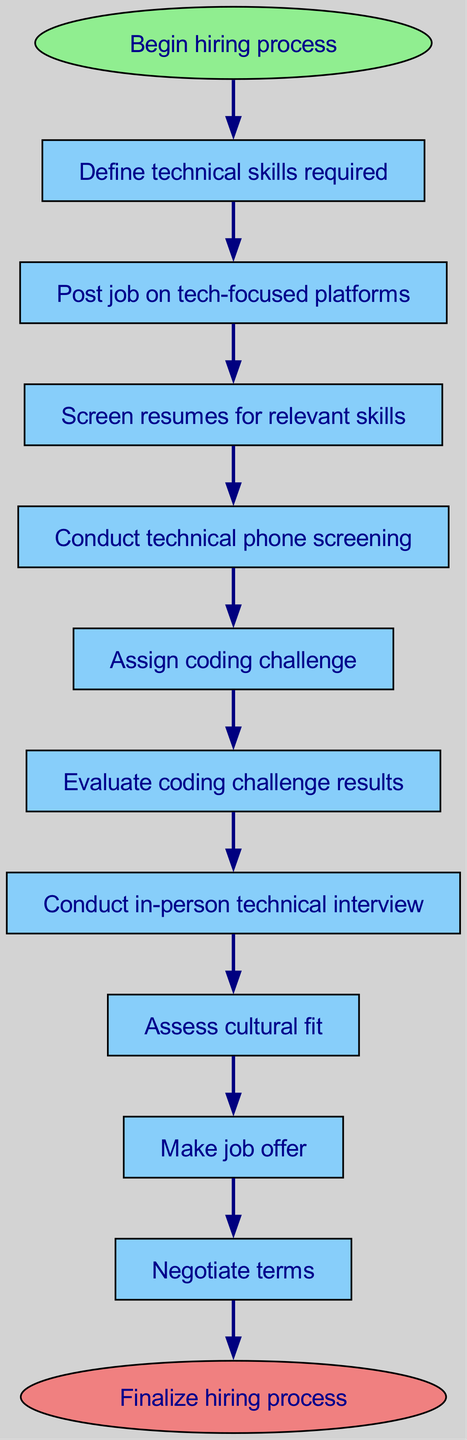What is the first step in the hiring process? The flowchart starts at the "Begin hiring process" node, which leads to the first step labeled "Define technical skills required."
Answer: Define technical skills required How many steps are there in the hiring process? The hiring process has a total of 10 steps (from define skills to negotiate terms). This is verified by counting the steps listed in the diagram.
Answer: 10 What follows after "Conduct in-person technical interview"? The node "Conduct in-person technical interview" is followed by "Assess cultural fit," which means the next step is determining how well the candidate fits the company culture.
Answer: Assess cultural fit Which step involves screening resumes? The step that involves screening resumes is labeled "Screen resumes for relevant skills," which is the third step in the sequence.
Answer: Screen resumes for relevant skills What is the last step in the hiring process? The last step in the diagram is "Negotiate terms," which directly leads to the end of the process. It is the final action taken before finalizing the hiring process.
Answer: Negotiate terms Which steps are directly related to the candidate's technical abilities? The steps related to the candidate's technical abilities include "Conduct technical phone screening," "Assign coding challenge," and "Evaluate coding challenge results." These steps assess the candidate's technical skills in various ways.
Answer: Conduct technical phone screening, Assign coding challenge, Evaluate coding challenge results How does the hiring process start? The hiring process starts with the initial node labeled "Begin hiring process," leading directly to defining required skills.
Answer: Begin hiring process What is the relationship between "Evaluate coding challenge results" and "Conduct in-person technical interview"? "Evaluate coding challenge results" is a prerequisite to "Conduct in-person technical interview," meaning the evaluation must occur before the candidate can proceed to the in-person interview stage.
Answer: Preceding step 